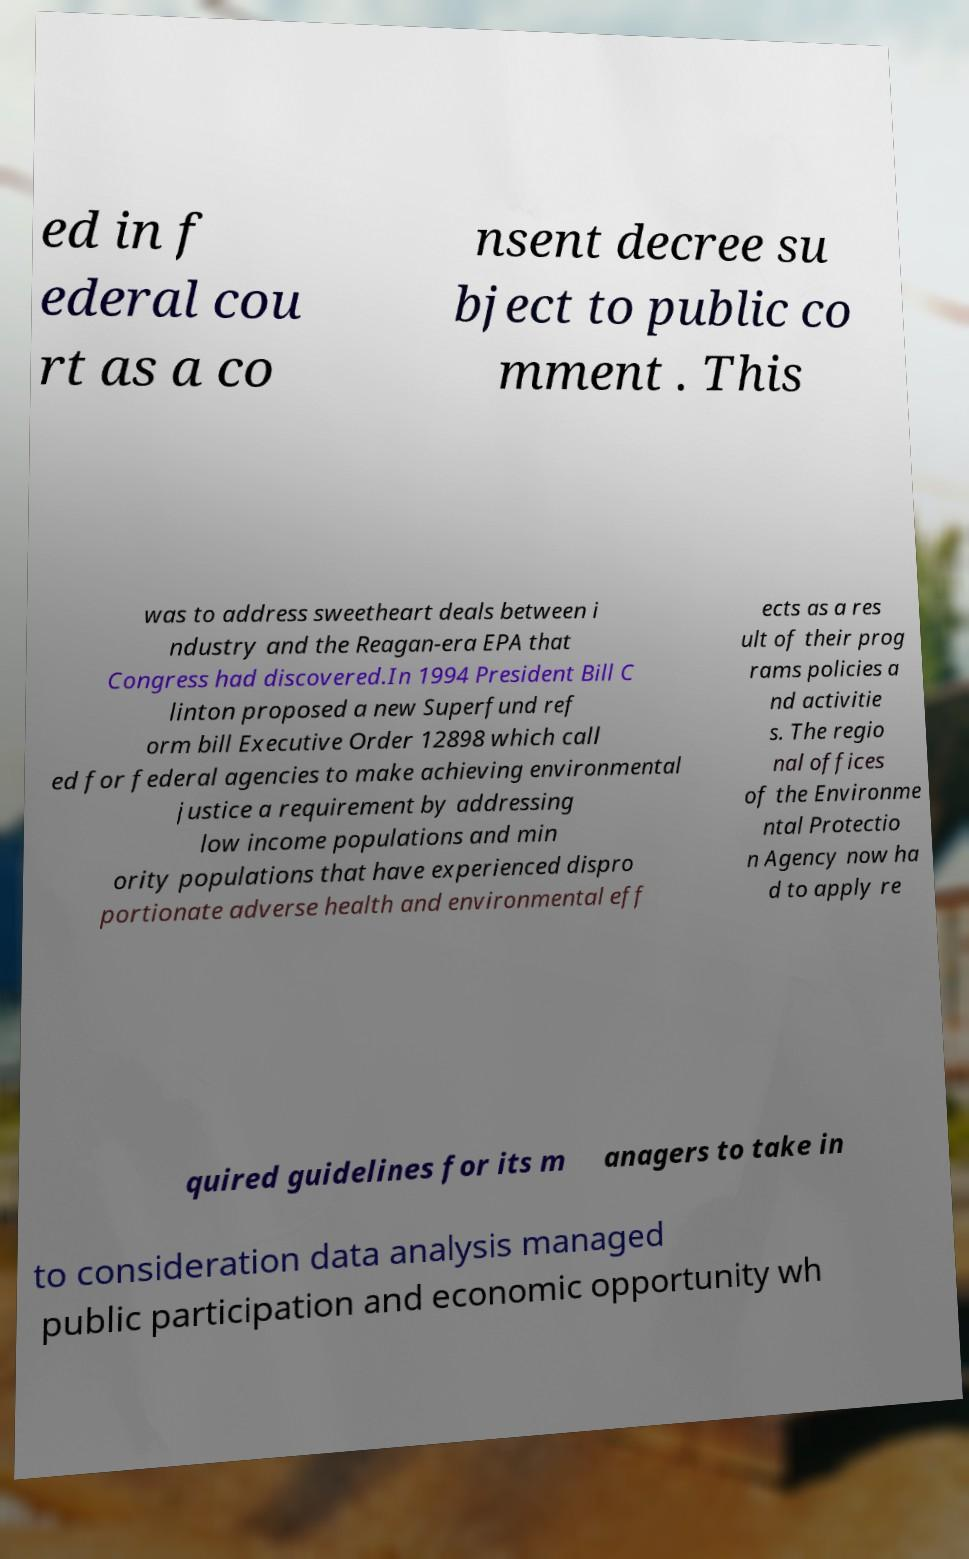Please identify and transcribe the text found in this image. ed in f ederal cou rt as a co nsent decree su bject to public co mment . This was to address sweetheart deals between i ndustry and the Reagan-era EPA that Congress had discovered.In 1994 President Bill C linton proposed a new Superfund ref orm bill Executive Order 12898 which call ed for federal agencies to make achieving environmental justice a requirement by addressing low income populations and min ority populations that have experienced dispro portionate adverse health and environmental eff ects as a res ult of their prog rams policies a nd activitie s. The regio nal offices of the Environme ntal Protectio n Agency now ha d to apply re quired guidelines for its m anagers to take in to consideration data analysis managed public participation and economic opportunity wh 